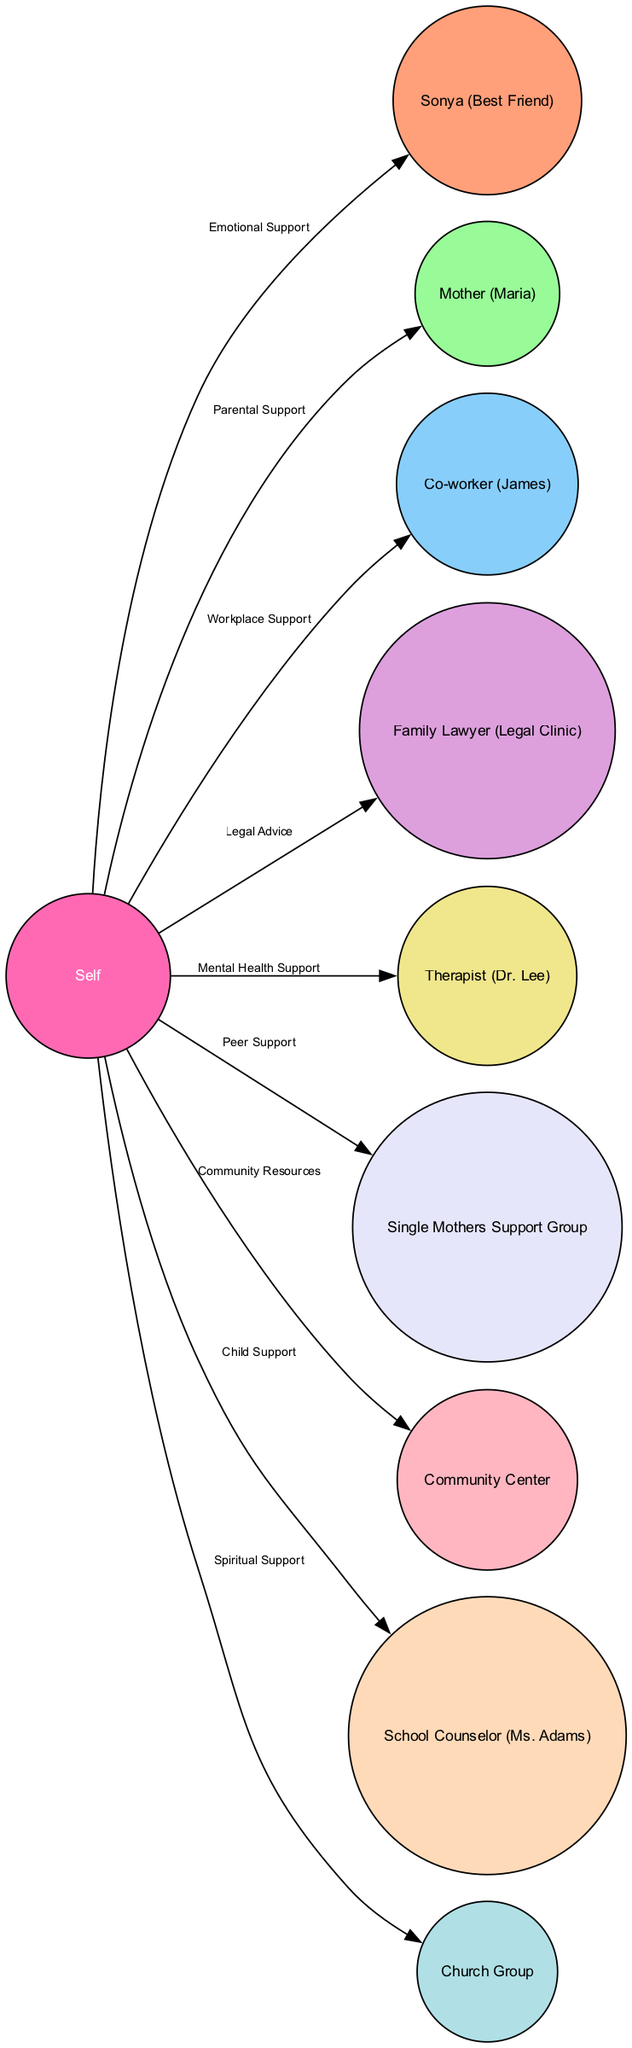What is the total number of nodes in the diagram? The diagram includes a list of nodes, which are each individuals or groups connected to the central figure (Self). Counting them, there are 10 nodes: Self, Sonya, Mother (Maria), Co-worker (James), Family Lawyer (Legal Clinic), Therapist (Dr. Lee), Single Mothers Support Group, Community Center, School Counselor (Ms. Adams), and Church Group.
Answer: 10 How many edges are connected to "Self"? The edges represent relationships from "Self" to other nodes. Counting these edges from "Self" to other nodes, there are 9 connections: to Sonya, Mother, Co-worker, Family Lawyer, Therapist, Single Mothers Support Group, Community Center, School Counselor, and Church Group.
Answer: 9 What type of support does "Therapist (Dr. Lee)" provide? The relationship between "Self" and "Therapist (Dr. Lee)" is labeled as "Mental Health Support." This indicates the specific type of support received from this node.
Answer: Mental Health Support Which node provides legal advice? The edge connecting "Self" to "Family Lawyer (Legal Clinic)" is labeled "Legal Advice," indicating that this node offers legal assistance.
Answer: Family Lawyer (Legal Clinic) What is the relationship between "Self" and "Single Mothers Support Group"? The edge linking "Self" to "Single Mothers Support Group" is identified as "Peer Support." This shows a specific supportive relationship focused on shared experiences among single mothers.
Answer: Peer Support Which two nodes are connected through "Workplace Support"? "Workplace Support" is the relationship between "Self" and "Co-worker (James)." This denotes that Co-worker (James) plays a role in providing workplace-related support to "Self."
Answer: Co-worker (James) Identify a node that offers community resources. The "Community Center" node is listed with a connection to "Self" indicating that it provides community resources to help with various needs.
Answer: Community Center What type of support does "Church Group" provide? The diagram shows that "Church Group" is linked to "Self" by the relationship labeled "Spiritual Support," indicating the type of assistance offered by this group.
Answer: Spiritual Support How many types of support are represented in the edges? There are 9 edges, each representing a different type of support including Emotional Support, Parental Support, Workplace Support, Legal Advice, Mental Health Support, Peer Support, Community Resources, Child Support, and Spiritual Support. Thus, there are 9 distinct types of support.
Answer: 9 